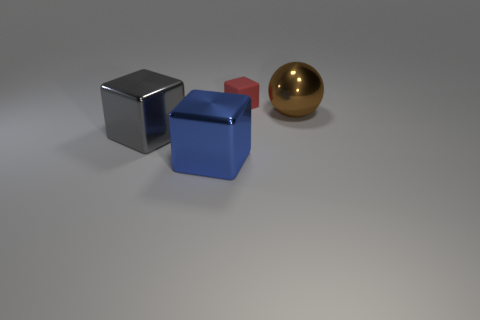Is there any other thing that is made of the same material as the big brown ball?
Your answer should be compact. Yes. Is there anything else that has the same color as the large metal ball?
Provide a short and direct response. No. What is the object to the right of the red matte block made of?
Your answer should be compact. Metal. Do the red object and the brown metallic ball have the same size?
Keep it short and to the point. No. What number of other things are there of the same size as the gray object?
Your response must be concise. 2. Is the small thing the same color as the shiny ball?
Your response must be concise. No. There is a big shiny object that is behind the large shiny thing left of the big metallic block that is to the right of the big gray block; what shape is it?
Give a very brief answer. Sphere. How many things are either metal things on the left side of the big ball or things that are on the left side of the large brown metal object?
Provide a short and direct response. 3. There is a metal object on the right side of the cube that is behind the big brown metal ball; how big is it?
Keep it short and to the point. Large. There is a object to the right of the red cube; does it have the same color as the small block?
Provide a succinct answer. No. 